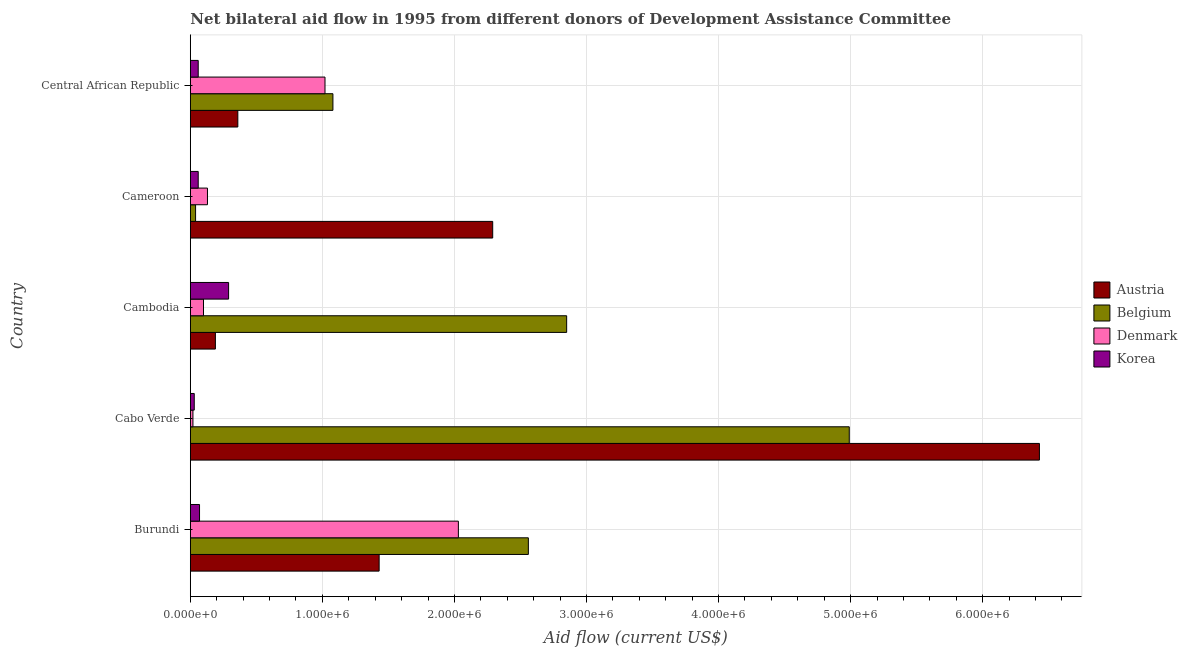How many bars are there on the 4th tick from the bottom?
Keep it short and to the point. 4. What is the label of the 2nd group of bars from the top?
Make the answer very short. Cameroon. In how many cases, is the number of bars for a given country not equal to the number of legend labels?
Provide a succinct answer. 0. What is the amount of aid given by belgium in Cameroon?
Offer a terse response. 4.00e+04. Across all countries, what is the maximum amount of aid given by belgium?
Give a very brief answer. 4.99e+06. Across all countries, what is the minimum amount of aid given by denmark?
Keep it short and to the point. 2.00e+04. In which country was the amount of aid given by belgium maximum?
Ensure brevity in your answer.  Cabo Verde. In which country was the amount of aid given by belgium minimum?
Your response must be concise. Cameroon. What is the total amount of aid given by korea in the graph?
Make the answer very short. 5.10e+05. What is the difference between the amount of aid given by denmark in Cameroon and that in Central African Republic?
Your answer should be compact. -8.90e+05. What is the difference between the amount of aid given by austria in Cameroon and the amount of aid given by belgium in Cabo Verde?
Make the answer very short. -2.70e+06. What is the average amount of aid given by denmark per country?
Your answer should be compact. 6.60e+05. What is the difference between the amount of aid given by austria and amount of aid given by denmark in Burundi?
Your answer should be very brief. -6.00e+05. What is the ratio of the amount of aid given by austria in Burundi to that in Cameroon?
Provide a succinct answer. 0.62. What is the difference between the highest and the second highest amount of aid given by belgium?
Offer a terse response. 2.14e+06. What is the difference between the highest and the lowest amount of aid given by korea?
Offer a very short reply. 2.60e+05. In how many countries, is the amount of aid given by austria greater than the average amount of aid given by austria taken over all countries?
Give a very brief answer. 2. What does the 2nd bar from the top in Cambodia represents?
Give a very brief answer. Denmark. What is the difference between two consecutive major ticks on the X-axis?
Your answer should be compact. 1.00e+06. Are the values on the major ticks of X-axis written in scientific E-notation?
Offer a terse response. Yes. How many legend labels are there?
Your answer should be compact. 4. What is the title of the graph?
Make the answer very short. Net bilateral aid flow in 1995 from different donors of Development Assistance Committee. Does "Water" appear as one of the legend labels in the graph?
Offer a terse response. No. What is the Aid flow (current US$) in Austria in Burundi?
Your answer should be very brief. 1.43e+06. What is the Aid flow (current US$) of Belgium in Burundi?
Offer a terse response. 2.56e+06. What is the Aid flow (current US$) in Denmark in Burundi?
Your answer should be compact. 2.03e+06. What is the Aid flow (current US$) in Korea in Burundi?
Keep it short and to the point. 7.00e+04. What is the Aid flow (current US$) of Austria in Cabo Verde?
Your response must be concise. 6.43e+06. What is the Aid flow (current US$) in Belgium in Cabo Verde?
Your answer should be very brief. 4.99e+06. What is the Aid flow (current US$) in Denmark in Cabo Verde?
Keep it short and to the point. 2.00e+04. What is the Aid flow (current US$) of Belgium in Cambodia?
Make the answer very short. 2.85e+06. What is the Aid flow (current US$) of Denmark in Cambodia?
Give a very brief answer. 1.00e+05. What is the Aid flow (current US$) of Austria in Cameroon?
Offer a very short reply. 2.29e+06. What is the Aid flow (current US$) of Belgium in Cameroon?
Provide a succinct answer. 4.00e+04. What is the Aid flow (current US$) in Austria in Central African Republic?
Your answer should be compact. 3.60e+05. What is the Aid flow (current US$) of Belgium in Central African Republic?
Offer a terse response. 1.08e+06. What is the Aid flow (current US$) in Denmark in Central African Republic?
Keep it short and to the point. 1.02e+06. What is the Aid flow (current US$) in Korea in Central African Republic?
Your answer should be compact. 6.00e+04. Across all countries, what is the maximum Aid flow (current US$) of Austria?
Give a very brief answer. 6.43e+06. Across all countries, what is the maximum Aid flow (current US$) of Belgium?
Offer a terse response. 4.99e+06. Across all countries, what is the maximum Aid flow (current US$) in Denmark?
Offer a very short reply. 2.03e+06. Across all countries, what is the maximum Aid flow (current US$) in Korea?
Give a very brief answer. 2.90e+05. Across all countries, what is the minimum Aid flow (current US$) of Belgium?
Your answer should be compact. 4.00e+04. Across all countries, what is the minimum Aid flow (current US$) of Denmark?
Provide a succinct answer. 2.00e+04. What is the total Aid flow (current US$) in Austria in the graph?
Offer a terse response. 1.07e+07. What is the total Aid flow (current US$) of Belgium in the graph?
Offer a terse response. 1.15e+07. What is the total Aid flow (current US$) of Denmark in the graph?
Give a very brief answer. 3.30e+06. What is the total Aid flow (current US$) in Korea in the graph?
Your answer should be compact. 5.10e+05. What is the difference between the Aid flow (current US$) in Austria in Burundi and that in Cabo Verde?
Your answer should be very brief. -5.00e+06. What is the difference between the Aid flow (current US$) in Belgium in Burundi and that in Cabo Verde?
Make the answer very short. -2.43e+06. What is the difference between the Aid flow (current US$) of Denmark in Burundi and that in Cabo Verde?
Give a very brief answer. 2.01e+06. What is the difference between the Aid flow (current US$) of Austria in Burundi and that in Cambodia?
Give a very brief answer. 1.24e+06. What is the difference between the Aid flow (current US$) of Denmark in Burundi and that in Cambodia?
Your answer should be compact. 1.93e+06. What is the difference between the Aid flow (current US$) in Austria in Burundi and that in Cameroon?
Give a very brief answer. -8.60e+05. What is the difference between the Aid flow (current US$) of Belgium in Burundi and that in Cameroon?
Your answer should be very brief. 2.52e+06. What is the difference between the Aid flow (current US$) in Denmark in Burundi and that in Cameroon?
Your answer should be very brief. 1.90e+06. What is the difference between the Aid flow (current US$) in Korea in Burundi and that in Cameroon?
Ensure brevity in your answer.  10000. What is the difference between the Aid flow (current US$) of Austria in Burundi and that in Central African Republic?
Offer a very short reply. 1.07e+06. What is the difference between the Aid flow (current US$) in Belgium in Burundi and that in Central African Republic?
Ensure brevity in your answer.  1.48e+06. What is the difference between the Aid flow (current US$) in Denmark in Burundi and that in Central African Republic?
Keep it short and to the point. 1.01e+06. What is the difference between the Aid flow (current US$) of Austria in Cabo Verde and that in Cambodia?
Ensure brevity in your answer.  6.24e+06. What is the difference between the Aid flow (current US$) in Belgium in Cabo Verde and that in Cambodia?
Ensure brevity in your answer.  2.14e+06. What is the difference between the Aid flow (current US$) in Denmark in Cabo Verde and that in Cambodia?
Your response must be concise. -8.00e+04. What is the difference between the Aid flow (current US$) of Austria in Cabo Verde and that in Cameroon?
Keep it short and to the point. 4.14e+06. What is the difference between the Aid flow (current US$) in Belgium in Cabo Verde and that in Cameroon?
Make the answer very short. 4.95e+06. What is the difference between the Aid flow (current US$) of Denmark in Cabo Verde and that in Cameroon?
Provide a succinct answer. -1.10e+05. What is the difference between the Aid flow (current US$) in Korea in Cabo Verde and that in Cameroon?
Ensure brevity in your answer.  -3.00e+04. What is the difference between the Aid flow (current US$) in Austria in Cabo Verde and that in Central African Republic?
Make the answer very short. 6.07e+06. What is the difference between the Aid flow (current US$) in Belgium in Cabo Verde and that in Central African Republic?
Offer a terse response. 3.91e+06. What is the difference between the Aid flow (current US$) of Korea in Cabo Verde and that in Central African Republic?
Your response must be concise. -3.00e+04. What is the difference between the Aid flow (current US$) of Austria in Cambodia and that in Cameroon?
Ensure brevity in your answer.  -2.10e+06. What is the difference between the Aid flow (current US$) of Belgium in Cambodia and that in Cameroon?
Make the answer very short. 2.81e+06. What is the difference between the Aid flow (current US$) of Korea in Cambodia and that in Cameroon?
Your answer should be compact. 2.30e+05. What is the difference between the Aid flow (current US$) of Austria in Cambodia and that in Central African Republic?
Provide a short and direct response. -1.70e+05. What is the difference between the Aid flow (current US$) of Belgium in Cambodia and that in Central African Republic?
Give a very brief answer. 1.77e+06. What is the difference between the Aid flow (current US$) of Denmark in Cambodia and that in Central African Republic?
Keep it short and to the point. -9.20e+05. What is the difference between the Aid flow (current US$) of Korea in Cambodia and that in Central African Republic?
Offer a terse response. 2.30e+05. What is the difference between the Aid flow (current US$) in Austria in Cameroon and that in Central African Republic?
Ensure brevity in your answer.  1.93e+06. What is the difference between the Aid flow (current US$) of Belgium in Cameroon and that in Central African Republic?
Offer a very short reply. -1.04e+06. What is the difference between the Aid flow (current US$) of Denmark in Cameroon and that in Central African Republic?
Provide a succinct answer. -8.90e+05. What is the difference between the Aid flow (current US$) in Austria in Burundi and the Aid flow (current US$) in Belgium in Cabo Verde?
Ensure brevity in your answer.  -3.56e+06. What is the difference between the Aid flow (current US$) in Austria in Burundi and the Aid flow (current US$) in Denmark in Cabo Verde?
Provide a succinct answer. 1.41e+06. What is the difference between the Aid flow (current US$) in Austria in Burundi and the Aid flow (current US$) in Korea in Cabo Verde?
Provide a short and direct response. 1.40e+06. What is the difference between the Aid flow (current US$) in Belgium in Burundi and the Aid flow (current US$) in Denmark in Cabo Verde?
Offer a very short reply. 2.54e+06. What is the difference between the Aid flow (current US$) of Belgium in Burundi and the Aid flow (current US$) of Korea in Cabo Verde?
Make the answer very short. 2.53e+06. What is the difference between the Aid flow (current US$) of Denmark in Burundi and the Aid flow (current US$) of Korea in Cabo Verde?
Provide a short and direct response. 2.00e+06. What is the difference between the Aid flow (current US$) of Austria in Burundi and the Aid flow (current US$) of Belgium in Cambodia?
Give a very brief answer. -1.42e+06. What is the difference between the Aid flow (current US$) of Austria in Burundi and the Aid flow (current US$) of Denmark in Cambodia?
Give a very brief answer. 1.33e+06. What is the difference between the Aid flow (current US$) in Austria in Burundi and the Aid flow (current US$) in Korea in Cambodia?
Keep it short and to the point. 1.14e+06. What is the difference between the Aid flow (current US$) of Belgium in Burundi and the Aid flow (current US$) of Denmark in Cambodia?
Offer a terse response. 2.46e+06. What is the difference between the Aid flow (current US$) of Belgium in Burundi and the Aid flow (current US$) of Korea in Cambodia?
Your answer should be compact. 2.27e+06. What is the difference between the Aid flow (current US$) of Denmark in Burundi and the Aid flow (current US$) of Korea in Cambodia?
Your answer should be very brief. 1.74e+06. What is the difference between the Aid flow (current US$) in Austria in Burundi and the Aid flow (current US$) in Belgium in Cameroon?
Offer a terse response. 1.39e+06. What is the difference between the Aid flow (current US$) in Austria in Burundi and the Aid flow (current US$) in Denmark in Cameroon?
Offer a terse response. 1.30e+06. What is the difference between the Aid flow (current US$) in Austria in Burundi and the Aid flow (current US$) in Korea in Cameroon?
Make the answer very short. 1.37e+06. What is the difference between the Aid flow (current US$) of Belgium in Burundi and the Aid flow (current US$) of Denmark in Cameroon?
Offer a very short reply. 2.43e+06. What is the difference between the Aid flow (current US$) of Belgium in Burundi and the Aid flow (current US$) of Korea in Cameroon?
Your answer should be compact. 2.50e+06. What is the difference between the Aid flow (current US$) of Denmark in Burundi and the Aid flow (current US$) of Korea in Cameroon?
Offer a terse response. 1.97e+06. What is the difference between the Aid flow (current US$) in Austria in Burundi and the Aid flow (current US$) in Belgium in Central African Republic?
Provide a short and direct response. 3.50e+05. What is the difference between the Aid flow (current US$) in Austria in Burundi and the Aid flow (current US$) in Korea in Central African Republic?
Offer a very short reply. 1.37e+06. What is the difference between the Aid flow (current US$) of Belgium in Burundi and the Aid flow (current US$) of Denmark in Central African Republic?
Ensure brevity in your answer.  1.54e+06. What is the difference between the Aid flow (current US$) of Belgium in Burundi and the Aid flow (current US$) of Korea in Central African Republic?
Your response must be concise. 2.50e+06. What is the difference between the Aid flow (current US$) of Denmark in Burundi and the Aid flow (current US$) of Korea in Central African Republic?
Your answer should be compact. 1.97e+06. What is the difference between the Aid flow (current US$) of Austria in Cabo Verde and the Aid flow (current US$) of Belgium in Cambodia?
Ensure brevity in your answer.  3.58e+06. What is the difference between the Aid flow (current US$) in Austria in Cabo Verde and the Aid flow (current US$) in Denmark in Cambodia?
Make the answer very short. 6.33e+06. What is the difference between the Aid flow (current US$) in Austria in Cabo Verde and the Aid flow (current US$) in Korea in Cambodia?
Offer a very short reply. 6.14e+06. What is the difference between the Aid flow (current US$) of Belgium in Cabo Verde and the Aid flow (current US$) of Denmark in Cambodia?
Ensure brevity in your answer.  4.89e+06. What is the difference between the Aid flow (current US$) of Belgium in Cabo Verde and the Aid flow (current US$) of Korea in Cambodia?
Ensure brevity in your answer.  4.70e+06. What is the difference between the Aid flow (current US$) in Austria in Cabo Verde and the Aid flow (current US$) in Belgium in Cameroon?
Your response must be concise. 6.39e+06. What is the difference between the Aid flow (current US$) of Austria in Cabo Verde and the Aid flow (current US$) of Denmark in Cameroon?
Your answer should be very brief. 6.30e+06. What is the difference between the Aid flow (current US$) of Austria in Cabo Verde and the Aid flow (current US$) of Korea in Cameroon?
Make the answer very short. 6.37e+06. What is the difference between the Aid flow (current US$) in Belgium in Cabo Verde and the Aid flow (current US$) in Denmark in Cameroon?
Provide a short and direct response. 4.86e+06. What is the difference between the Aid flow (current US$) in Belgium in Cabo Verde and the Aid flow (current US$) in Korea in Cameroon?
Your answer should be compact. 4.93e+06. What is the difference between the Aid flow (current US$) in Austria in Cabo Verde and the Aid flow (current US$) in Belgium in Central African Republic?
Provide a short and direct response. 5.35e+06. What is the difference between the Aid flow (current US$) in Austria in Cabo Verde and the Aid flow (current US$) in Denmark in Central African Republic?
Your answer should be very brief. 5.41e+06. What is the difference between the Aid flow (current US$) of Austria in Cabo Verde and the Aid flow (current US$) of Korea in Central African Republic?
Provide a succinct answer. 6.37e+06. What is the difference between the Aid flow (current US$) of Belgium in Cabo Verde and the Aid flow (current US$) of Denmark in Central African Republic?
Make the answer very short. 3.97e+06. What is the difference between the Aid flow (current US$) in Belgium in Cabo Verde and the Aid flow (current US$) in Korea in Central African Republic?
Keep it short and to the point. 4.93e+06. What is the difference between the Aid flow (current US$) of Austria in Cambodia and the Aid flow (current US$) of Belgium in Cameroon?
Offer a terse response. 1.50e+05. What is the difference between the Aid flow (current US$) in Austria in Cambodia and the Aid flow (current US$) in Denmark in Cameroon?
Your answer should be very brief. 6.00e+04. What is the difference between the Aid flow (current US$) in Belgium in Cambodia and the Aid flow (current US$) in Denmark in Cameroon?
Give a very brief answer. 2.72e+06. What is the difference between the Aid flow (current US$) of Belgium in Cambodia and the Aid flow (current US$) of Korea in Cameroon?
Your answer should be very brief. 2.79e+06. What is the difference between the Aid flow (current US$) in Denmark in Cambodia and the Aid flow (current US$) in Korea in Cameroon?
Provide a short and direct response. 4.00e+04. What is the difference between the Aid flow (current US$) of Austria in Cambodia and the Aid flow (current US$) of Belgium in Central African Republic?
Give a very brief answer. -8.90e+05. What is the difference between the Aid flow (current US$) of Austria in Cambodia and the Aid flow (current US$) of Denmark in Central African Republic?
Make the answer very short. -8.30e+05. What is the difference between the Aid flow (current US$) of Belgium in Cambodia and the Aid flow (current US$) of Denmark in Central African Republic?
Provide a short and direct response. 1.83e+06. What is the difference between the Aid flow (current US$) in Belgium in Cambodia and the Aid flow (current US$) in Korea in Central African Republic?
Your answer should be compact. 2.79e+06. What is the difference between the Aid flow (current US$) of Austria in Cameroon and the Aid flow (current US$) of Belgium in Central African Republic?
Ensure brevity in your answer.  1.21e+06. What is the difference between the Aid flow (current US$) in Austria in Cameroon and the Aid flow (current US$) in Denmark in Central African Republic?
Offer a terse response. 1.27e+06. What is the difference between the Aid flow (current US$) of Austria in Cameroon and the Aid flow (current US$) of Korea in Central African Republic?
Your response must be concise. 2.23e+06. What is the difference between the Aid flow (current US$) of Belgium in Cameroon and the Aid flow (current US$) of Denmark in Central African Republic?
Provide a succinct answer. -9.80e+05. What is the difference between the Aid flow (current US$) of Belgium in Cameroon and the Aid flow (current US$) of Korea in Central African Republic?
Offer a terse response. -2.00e+04. What is the difference between the Aid flow (current US$) in Denmark in Cameroon and the Aid flow (current US$) in Korea in Central African Republic?
Provide a succinct answer. 7.00e+04. What is the average Aid flow (current US$) of Austria per country?
Your answer should be very brief. 2.14e+06. What is the average Aid flow (current US$) of Belgium per country?
Your response must be concise. 2.30e+06. What is the average Aid flow (current US$) of Denmark per country?
Ensure brevity in your answer.  6.60e+05. What is the average Aid flow (current US$) of Korea per country?
Your response must be concise. 1.02e+05. What is the difference between the Aid flow (current US$) of Austria and Aid flow (current US$) of Belgium in Burundi?
Your answer should be compact. -1.13e+06. What is the difference between the Aid flow (current US$) in Austria and Aid flow (current US$) in Denmark in Burundi?
Offer a terse response. -6.00e+05. What is the difference between the Aid flow (current US$) in Austria and Aid flow (current US$) in Korea in Burundi?
Offer a terse response. 1.36e+06. What is the difference between the Aid flow (current US$) in Belgium and Aid flow (current US$) in Denmark in Burundi?
Your answer should be very brief. 5.30e+05. What is the difference between the Aid flow (current US$) of Belgium and Aid flow (current US$) of Korea in Burundi?
Offer a very short reply. 2.49e+06. What is the difference between the Aid flow (current US$) in Denmark and Aid flow (current US$) in Korea in Burundi?
Offer a terse response. 1.96e+06. What is the difference between the Aid flow (current US$) of Austria and Aid flow (current US$) of Belgium in Cabo Verde?
Provide a short and direct response. 1.44e+06. What is the difference between the Aid flow (current US$) of Austria and Aid flow (current US$) of Denmark in Cabo Verde?
Make the answer very short. 6.41e+06. What is the difference between the Aid flow (current US$) in Austria and Aid flow (current US$) in Korea in Cabo Verde?
Your answer should be compact. 6.40e+06. What is the difference between the Aid flow (current US$) of Belgium and Aid flow (current US$) of Denmark in Cabo Verde?
Provide a succinct answer. 4.97e+06. What is the difference between the Aid flow (current US$) of Belgium and Aid flow (current US$) of Korea in Cabo Verde?
Ensure brevity in your answer.  4.96e+06. What is the difference between the Aid flow (current US$) in Austria and Aid flow (current US$) in Belgium in Cambodia?
Your answer should be very brief. -2.66e+06. What is the difference between the Aid flow (current US$) in Austria and Aid flow (current US$) in Denmark in Cambodia?
Ensure brevity in your answer.  9.00e+04. What is the difference between the Aid flow (current US$) in Austria and Aid flow (current US$) in Korea in Cambodia?
Your answer should be very brief. -1.00e+05. What is the difference between the Aid flow (current US$) in Belgium and Aid flow (current US$) in Denmark in Cambodia?
Keep it short and to the point. 2.75e+06. What is the difference between the Aid flow (current US$) of Belgium and Aid flow (current US$) of Korea in Cambodia?
Offer a very short reply. 2.56e+06. What is the difference between the Aid flow (current US$) of Austria and Aid flow (current US$) of Belgium in Cameroon?
Provide a short and direct response. 2.25e+06. What is the difference between the Aid flow (current US$) in Austria and Aid flow (current US$) in Denmark in Cameroon?
Your answer should be very brief. 2.16e+06. What is the difference between the Aid flow (current US$) of Austria and Aid flow (current US$) of Korea in Cameroon?
Your answer should be compact. 2.23e+06. What is the difference between the Aid flow (current US$) in Belgium and Aid flow (current US$) in Denmark in Cameroon?
Give a very brief answer. -9.00e+04. What is the difference between the Aid flow (current US$) of Belgium and Aid flow (current US$) of Korea in Cameroon?
Provide a succinct answer. -2.00e+04. What is the difference between the Aid flow (current US$) in Denmark and Aid flow (current US$) in Korea in Cameroon?
Your answer should be very brief. 7.00e+04. What is the difference between the Aid flow (current US$) of Austria and Aid flow (current US$) of Belgium in Central African Republic?
Ensure brevity in your answer.  -7.20e+05. What is the difference between the Aid flow (current US$) in Austria and Aid flow (current US$) in Denmark in Central African Republic?
Your answer should be compact. -6.60e+05. What is the difference between the Aid flow (current US$) of Belgium and Aid flow (current US$) of Korea in Central African Republic?
Keep it short and to the point. 1.02e+06. What is the difference between the Aid flow (current US$) of Denmark and Aid flow (current US$) of Korea in Central African Republic?
Provide a succinct answer. 9.60e+05. What is the ratio of the Aid flow (current US$) of Austria in Burundi to that in Cabo Verde?
Provide a short and direct response. 0.22. What is the ratio of the Aid flow (current US$) in Belgium in Burundi to that in Cabo Verde?
Offer a very short reply. 0.51. What is the ratio of the Aid flow (current US$) in Denmark in Burundi to that in Cabo Verde?
Provide a succinct answer. 101.5. What is the ratio of the Aid flow (current US$) of Korea in Burundi to that in Cabo Verde?
Your response must be concise. 2.33. What is the ratio of the Aid flow (current US$) of Austria in Burundi to that in Cambodia?
Keep it short and to the point. 7.53. What is the ratio of the Aid flow (current US$) of Belgium in Burundi to that in Cambodia?
Your answer should be very brief. 0.9. What is the ratio of the Aid flow (current US$) of Denmark in Burundi to that in Cambodia?
Provide a succinct answer. 20.3. What is the ratio of the Aid flow (current US$) of Korea in Burundi to that in Cambodia?
Offer a terse response. 0.24. What is the ratio of the Aid flow (current US$) of Austria in Burundi to that in Cameroon?
Offer a very short reply. 0.62. What is the ratio of the Aid flow (current US$) of Denmark in Burundi to that in Cameroon?
Your response must be concise. 15.62. What is the ratio of the Aid flow (current US$) of Korea in Burundi to that in Cameroon?
Provide a short and direct response. 1.17. What is the ratio of the Aid flow (current US$) in Austria in Burundi to that in Central African Republic?
Your response must be concise. 3.97. What is the ratio of the Aid flow (current US$) of Belgium in Burundi to that in Central African Republic?
Give a very brief answer. 2.37. What is the ratio of the Aid flow (current US$) in Denmark in Burundi to that in Central African Republic?
Provide a short and direct response. 1.99. What is the ratio of the Aid flow (current US$) of Korea in Burundi to that in Central African Republic?
Keep it short and to the point. 1.17. What is the ratio of the Aid flow (current US$) in Austria in Cabo Verde to that in Cambodia?
Offer a terse response. 33.84. What is the ratio of the Aid flow (current US$) of Belgium in Cabo Verde to that in Cambodia?
Provide a succinct answer. 1.75. What is the ratio of the Aid flow (current US$) in Korea in Cabo Verde to that in Cambodia?
Make the answer very short. 0.1. What is the ratio of the Aid flow (current US$) of Austria in Cabo Verde to that in Cameroon?
Your response must be concise. 2.81. What is the ratio of the Aid flow (current US$) of Belgium in Cabo Verde to that in Cameroon?
Your answer should be very brief. 124.75. What is the ratio of the Aid flow (current US$) in Denmark in Cabo Verde to that in Cameroon?
Your answer should be compact. 0.15. What is the ratio of the Aid flow (current US$) in Austria in Cabo Verde to that in Central African Republic?
Provide a succinct answer. 17.86. What is the ratio of the Aid flow (current US$) of Belgium in Cabo Verde to that in Central African Republic?
Keep it short and to the point. 4.62. What is the ratio of the Aid flow (current US$) in Denmark in Cabo Verde to that in Central African Republic?
Provide a succinct answer. 0.02. What is the ratio of the Aid flow (current US$) in Austria in Cambodia to that in Cameroon?
Make the answer very short. 0.08. What is the ratio of the Aid flow (current US$) in Belgium in Cambodia to that in Cameroon?
Give a very brief answer. 71.25. What is the ratio of the Aid flow (current US$) of Denmark in Cambodia to that in Cameroon?
Your answer should be compact. 0.77. What is the ratio of the Aid flow (current US$) in Korea in Cambodia to that in Cameroon?
Your response must be concise. 4.83. What is the ratio of the Aid flow (current US$) of Austria in Cambodia to that in Central African Republic?
Give a very brief answer. 0.53. What is the ratio of the Aid flow (current US$) of Belgium in Cambodia to that in Central African Republic?
Offer a terse response. 2.64. What is the ratio of the Aid flow (current US$) in Denmark in Cambodia to that in Central African Republic?
Ensure brevity in your answer.  0.1. What is the ratio of the Aid flow (current US$) of Korea in Cambodia to that in Central African Republic?
Your response must be concise. 4.83. What is the ratio of the Aid flow (current US$) of Austria in Cameroon to that in Central African Republic?
Provide a short and direct response. 6.36. What is the ratio of the Aid flow (current US$) of Belgium in Cameroon to that in Central African Republic?
Provide a short and direct response. 0.04. What is the ratio of the Aid flow (current US$) in Denmark in Cameroon to that in Central African Republic?
Provide a short and direct response. 0.13. What is the ratio of the Aid flow (current US$) of Korea in Cameroon to that in Central African Republic?
Give a very brief answer. 1. What is the difference between the highest and the second highest Aid flow (current US$) of Austria?
Ensure brevity in your answer.  4.14e+06. What is the difference between the highest and the second highest Aid flow (current US$) of Belgium?
Ensure brevity in your answer.  2.14e+06. What is the difference between the highest and the second highest Aid flow (current US$) in Denmark?
Offer a terse response. 1.01e+06. What is the difference between the highest and the second highest Aid flow (current US$) in Korea?
Give a very brief answer. 2.20e+05. What is the difference between the highest and the lowest Aid flow (current US$) of Austria?
Give a very brief answer. 6.24e+06. What is the difference between the highest and the lowest Aid flow (current US$) in Belgium?
Your response must be concise. 4.95e+06. What is the difference between the highest and the lowest Aid flow (current US$) in Denmark?
Give a very brief answer. 2.01e+06. What is the difference between the highest and the lowest Aid flow (current US$) in Korea?
Give a very brief answer. 2.60e+05. 